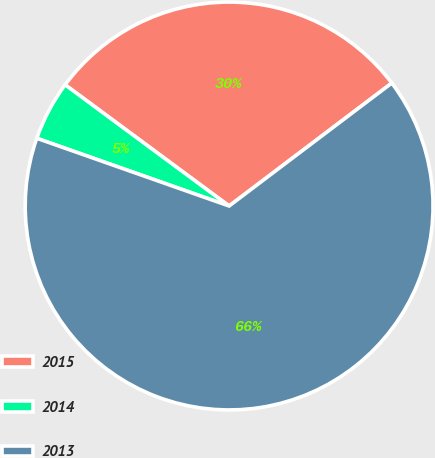<chart> <loc_0><loc_0><loc_500><loc_500><pie_chart><fcel>2015<fcel>2014<fcel>2013<nl><fcel>29.57%<fcel>4.74%<fcel>65.69%<nl></chart> 